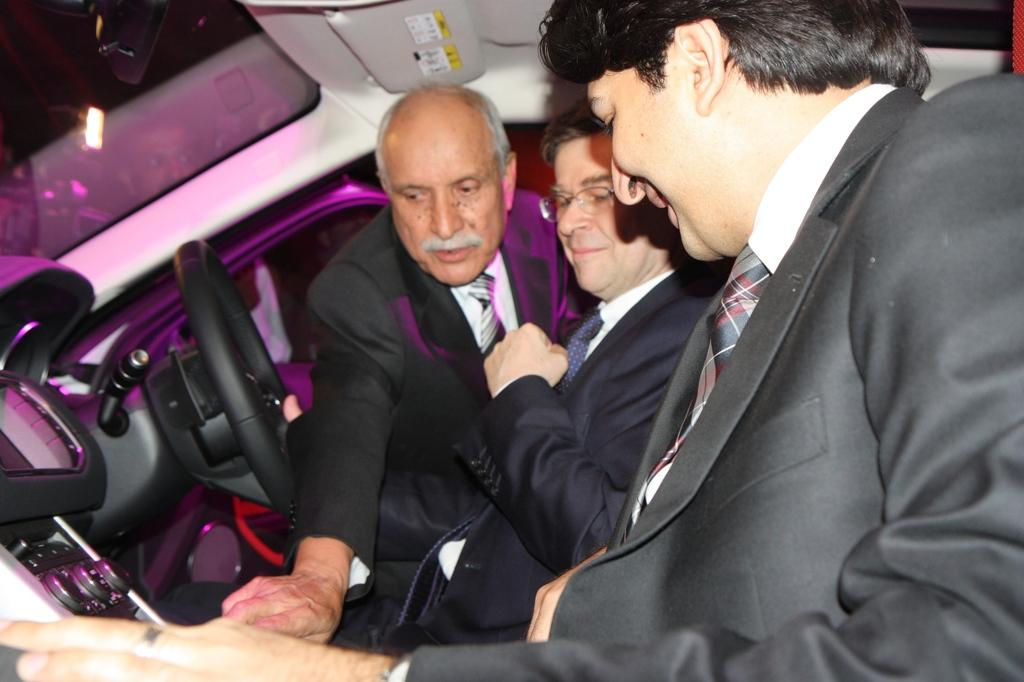How many people are in the car in the image? There are two persons sitting in a car in the image. What is happening with the person standing near the car? The standing person is showing something to the two persons in the car. Can you describe the interaction between the standing person and the people in the car? The standing person is communicating with the two persons in the car by showing them something. What type of cow can be seen grazing in the background of the image? There is no cow present in the image; it features two persons sitting in a car and a person standing near the car. What is the direction of the air current in the image? There is no mention of air currents in the image, as it focuses on the interaction between the people in and near the car. 